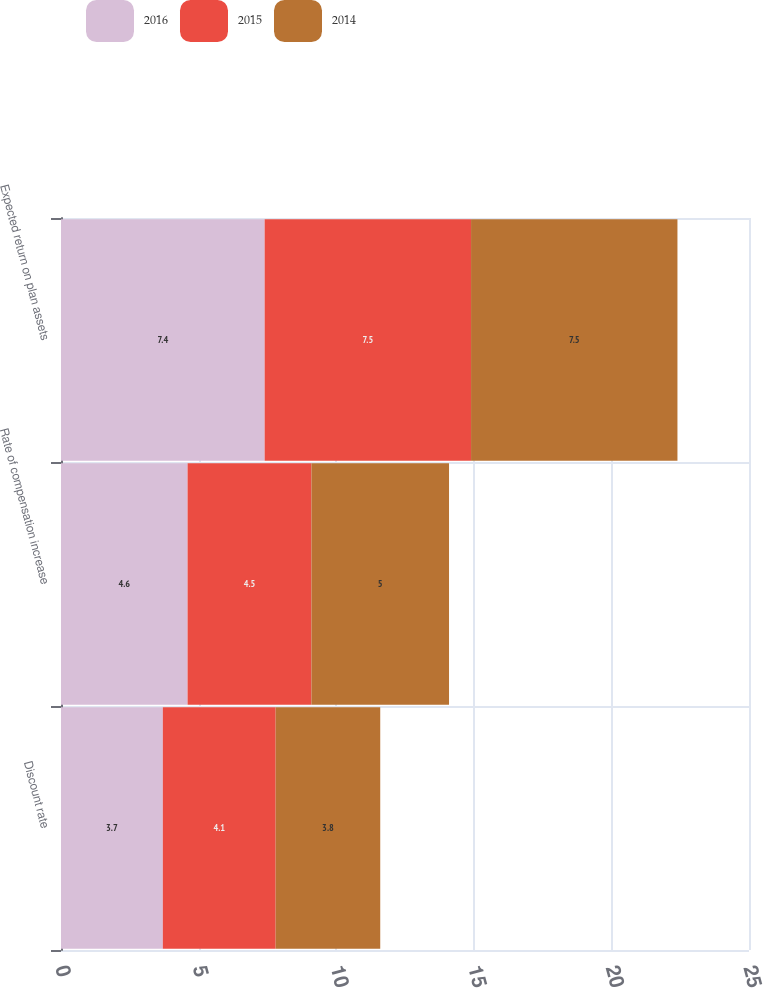Convert chart. <chart><loc_0><loc_0><loc_500><loc_500><stacked_bar_chart><ecel><fcel>Discount rate<fcel>Rate of compensation increase<fcel>Expected return on plan assets<nl><fcel>2016<fcel>3.7<fcel>4.6<fcel>7.4<nl><fcel>2015<fcel>4.1<fcel>4.5<fcel>7.5<nl><fcel>2014<fcel>3.8<fcel>5<fcel>7.5<nl></chart> 